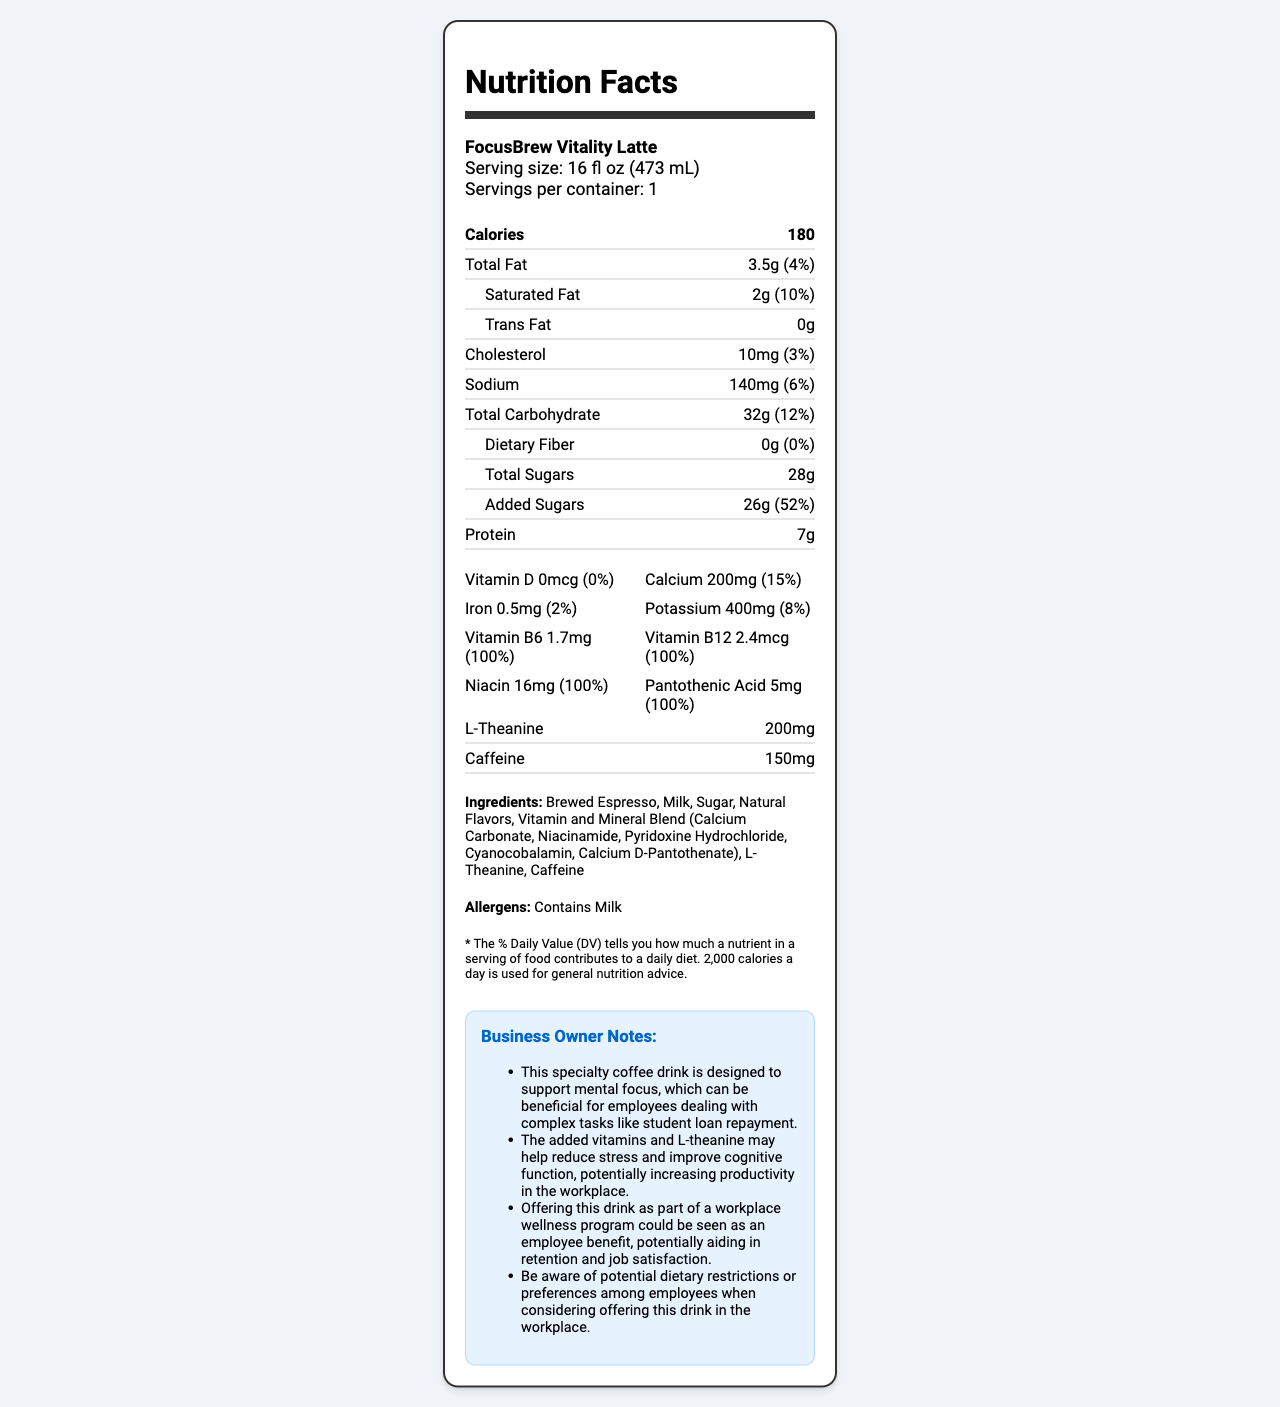what is the serving size of the FocusBrew Vitality Latte? The serving size is explicitly mentioned as "16 fl oz (473 mL)" in the serving info section.
Answer: 16 fl oz (473 mL) How many calories are in one serving of this coffee drink? The calories are listed as 180 in the nutrient section.
Answer: 180 How much saturated fat is in one serving, and what is its daily value percentage? The document states that the saturated fat amount is 2g and the daily value percentage is 10%.
Answer: 2g, 10% What vitamins and minerals are present in the FocusBrew Vitality Latte? These are listed under the vitamins section.
Answer: Vitamin D, Calcium, Iron, Potassium, Vitamin B6, Vitamin B12, Niacin, Pantothenic Acid How many grams of added sugars are included, and what is the daily value percentage? The added sugars are reported as 26g with a daily value percentage of 52%.
Answer: 26g, 52% Which ingredient listed might cause concerns for employees with allergies? A. Brewed Espresso B. Milk C. Sugar D. Natural Flavors The allergens section explicitly states "Contains Milk".
Answer: B What is the amount of protein in one serving? The protein content is clearly mentioned as 7g.
Answer: 7g Is there any dietary fiber in the FocusBrew Vitality Latte? The document shows 0g of dietary fiber.
Answer: No How much caffeine does this drink contain? The amount of caffeine is listed as 150mg.
Answer: 150mg Does this drink contain any trans fat? The trans fat amount is reported as 0g.
Answer: No What is one potential business benefit of offering this drink in the workplace, according to the business owner notes? One business owner note mentions that the added vitamins and L-theanine may help reduce stress and improve cognitive function, potentially increasing productivity in the workplace.
Answer: Increasing productivity in the workplace How much calcium is in one serving and its daily value percentage? The calcium content is listed as 200mg, with a daily value percentage of 15%.
Answer: 200mg, 15% What is the main idea of the document? The document is a detailed nutritional label for a specialty coffee drink with added vitamins, designed to support mental focus, along with business insights on its potential workplace benefits.
Answer: The document provides detailed nutritional information about the FocusBrew Vitality Latte, including calories, fat, cholesterol, sodium, carbohydrates, sugars, protein, vitamins, and minerals. It also includes business owner notes on how this drink may benefit employees' mental focus and productivity. How many servings are there per container of FocusBrew Vitality Latte? The document states that there is 1 serving per container.
Answer: 1 What percentage of the daily value of sodium does this drink provide? A. 3% B. 6% C. 10% D. 15% The document shows that the sodium content provides 6% of the daily value.
Answer: B Is there any cholesterol in this drink? The document states that there is 10mg of cholesterol, which is 3% of the daily value.
Answer: Yes Can the business owner determine if this drink fits the dietary restrictions for all employees? The document includes a note suggesting that the business owner needs to be aware of potential dietary restrictions or preferences among employees, indicating that the drink may not fit all dietary needs.
Answer: No 